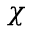<formula> <loc_0><loc_0><loc_500><loc_500>\chi</formula> 